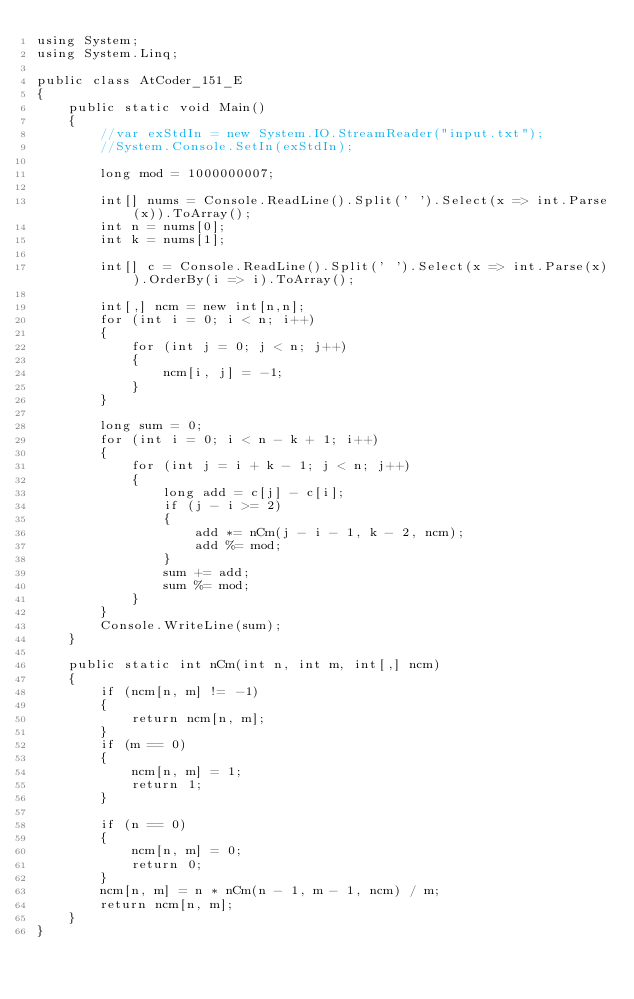Convert code to text. <code><loc_0><loc_0><loc_500><loc_500><_C#_>using System;
using System.Linq;

public class AtCoder_151_E
{
    public static void Main()
    {
        //var exStdIn = new System.IO.StreamReader("input.txt");
        //System.Console.SetIn(exStdIn);

        long mod = 1000000007;

        int[] nums = Console.ReadLine().Split(' ').Select(x => int.Parse(x)).ToArray();
        int n = nums[0];
        int k = nums[1];

        int[] c = Console.ReadLine().Split(' ').Select(x => int.Parse(x)).OrderBy(i => i).ToArray();

        int[,] ncm = new int[n,n];
        for (int i = 0; i < n; i++)
        {
            for (int j = 0; j < n; j++)
            {
                ncm[i, j] = -1;
            }
        }

        long sum = 0;
        for (int i = 0; i < n - k + 1; i++)
        {
            for (int j = i + k - 1; j < n; j++)
            {
                long add = c[j] - c[i];
                if (j - i >= 2)
                {
                    add *= nCm(j - i - 1, k - 2, ncm);
                    add %= mod;
                }
                sum += add;
                sum %= mod;
            }
        }
        Console.WriteLine(sum);
    }

    public static int nCm(int n, int m, int[,] ncm)
    {
        if (ncm[n, m] != -1)
        {
            return ncm[n, m];
        }
        if (m == 0)
        {
            ncm[n, m] = 1;
            return 1;
        }

        if (n == 0)
        {
            ncm[n, m] = 0;
            return 0;
        }
        ncm[n, m] = n * nCm(n - 1, m - 1, ncm) / m;
        return ncm[n, m];
    }
}
</code> 